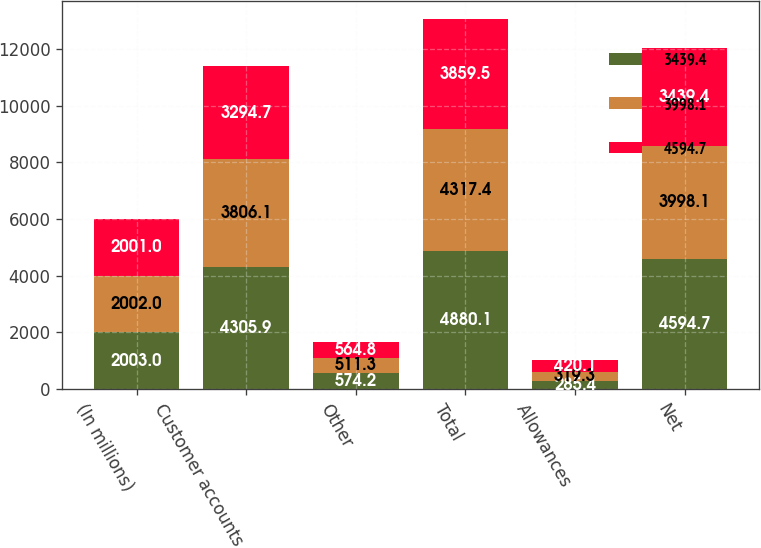Convert chart to OTSL. <chart><loc_0><loc_0><loc_500><loc_500><stacked_bar_chart><ecel><fcel>(In millions)<fcel>Customer accounts<fcel>Other<fcel>Total<fcel>Allowances<fcel>Net<nl><fcel>3439.4<fcel>2003<fcel>4305.9<fcel>574.2<fcel>4880.1<fcel>285.4<fcel>4594.7<nl><fcel>3998.1<fcel>2002<fcel>3806.1<fcel>511.3<fcel>4317.4<fcel>319.3<fcel>3998.1<nl><fcel>4594.7<fcel>2001<fcel>3294.7<fcel>564.8<fcel>3859.5<fcel>420.1<fcel>3439.4<nl></chart> 